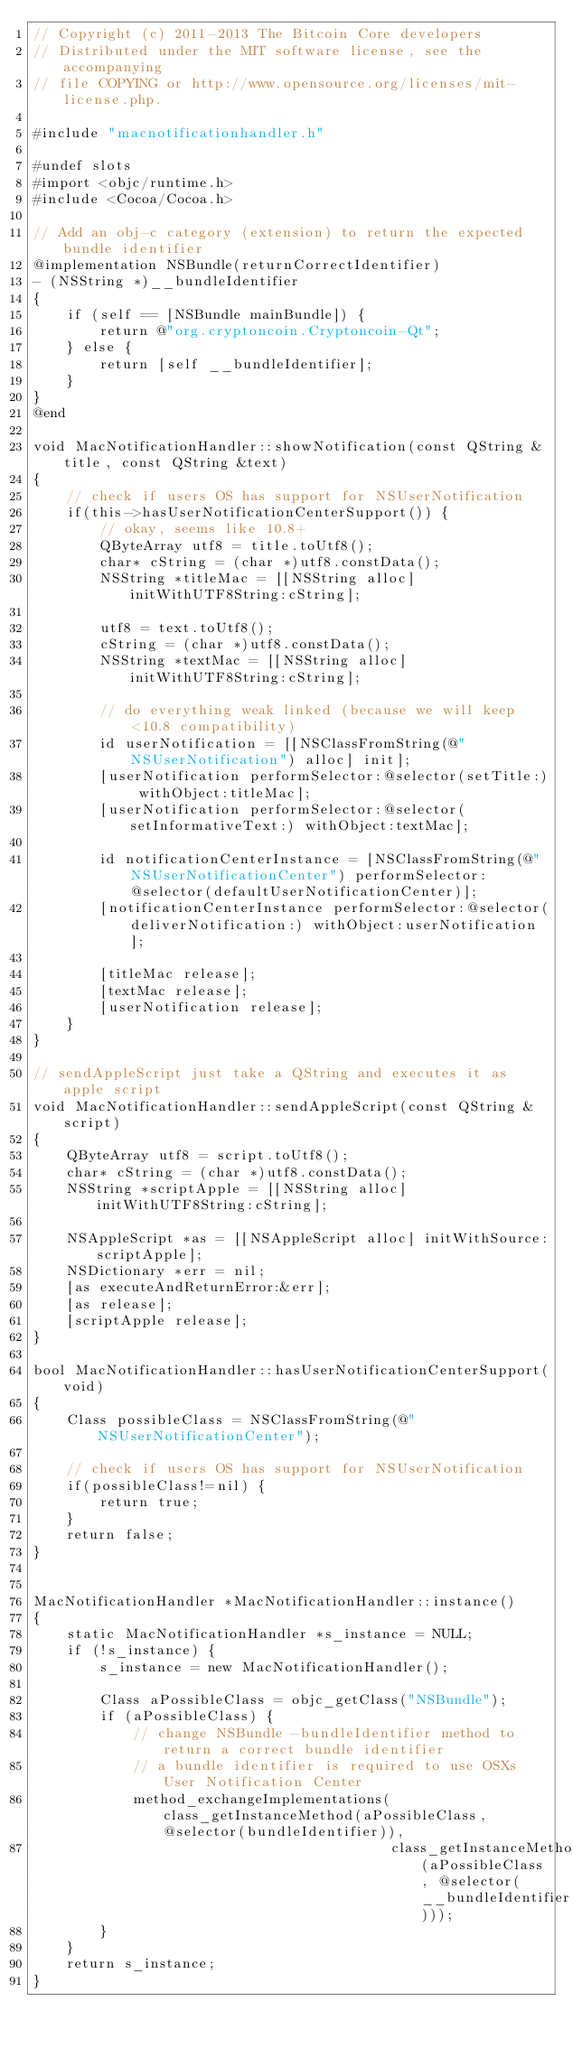<code> <loc_0><loc_0><loc_500><loc_500><_ObjectiveC_>// Copyright (c) 2011-2013 The Bitcoin Core developers
// Distributed under the MIT software license, see the accompanying
// file COPYING or http://www.opensource.org/licenses/mit-license.php.

#include "macnotificationhandler.h"

#undef slots
#import <objc/runtime.h>
#include <Cocoa/Cocoa.h>

// Add an obj-c category (extension) to return the expected bundle identifier
@implementation NSBundle(returnCorrectIdentifier)
- (NSString *)__bundleIdentifier
{
    if (self == [NSBundle mainBundle]) {
        return @"org.cryptoncoin.Cryptoncoin-Qt";
    } else {
        return [self __bundleIdentifier];
    }
}
@end

void MacNotificationHandler::showNotification(const QString &title, const QString &text)
{
    // check if users OS has support for NSUserNotification
    if(this->hasUserNotificationCenterSupport()) {
        // okay, seems like 10.8+
        QByteArray utf8 = title.toUtf8();
        char* cString = (char *)utf8.constData();
        NSString *titleMac = [[NSString alloc] initWithUTF8String:cString];

        utf8 = text.toUtf8();
        cString = (char *)utf8.constData();
        NSString *textMac = [[NSString alloc] initWithUTF8String:cString];

        // do everything weak linked (because we will keep <10.8 compatibility)
        id userNotification = [[NSClassFromString(@"NSUserNotification") alloc] init];
        [userNotification performSelector:@selector(setTitle:) withObject:titleMac];
        [userNotification performSelector:@selector(setInformativeText:) withObject:textMac];

        id notificationCenterInstance = [NSClassFromString(@"NSUserNotificationCenter") performSelector:@selector(defaultUserNotificationCenter)];
        [notificationCenterInstance performSelector:@selector(deliverNotification:) withObject:userNotification];

        [titleMac release];
        [textMac release];
        [userNotification release];
    }
}

// sendAppleScript just take a QString and executes it as apple script
void MacNotificationHandler::sendAppleScript(const QString &script)
{
    QByteArray utf8 = script.toUtf8();
    char* cString = (char *)utf8.constData();
    NSString *scriptApple = [[NSString alloc] initWithUTF8String:cString];

    NSAppleScript *as = [[NSAppleScript alloc] initWithSource:scriptApple];
    NSDictionary *err = nil;
    [as executeAndReturnError:&err];
    [as release];
    [scriptApple release];
}

bool MacNotificationHandler::hasUserNotificationCenterSupport(void)
{
    Class possibleClass = NSClassFromString(@"NSUserNotificationCenter");

    // check if users OS has support for NSUserNotification
    if(possibleClass!=nil) {
        return true;
    }
    return false;
}


MacNotificationHandler *MacNotificationHandler::instance()
{
    static MacNotificationHandler *s_instance = NULL;
    if (!s_instance) {
        s_instance = new MacNotificationHandler();
        
        Class aPossibleClass = objc_getClass("NSBundle");
        if (aPossibleClass) {
            // change NSBundle -bundleIdentifier method to return a correct bundle identifier
            // a bundle identifier is required to use OSXs User Notification Center
            method_exchangeImplementations(class_getInstanceMethod(aPossibleClass, @selector(bundleIdentifier)),
                                           class_getInstanceMethod(aPossibleClass, @selector(__bundleIdentifier)));
        }
    }
    return s_instance;
}
</code> 